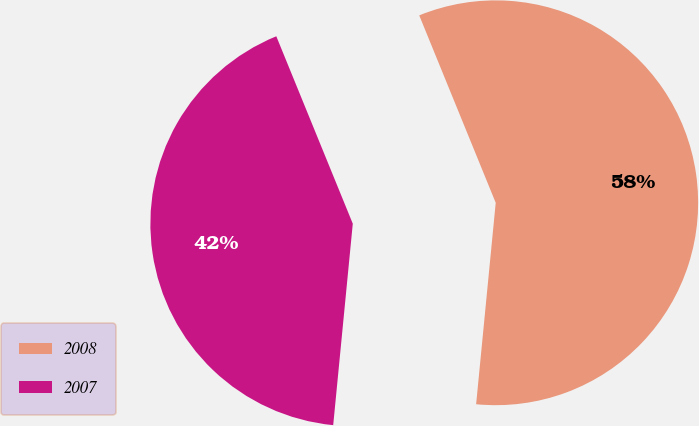<chart> <loc_0><loc_0><loc_500><loc_500><pie_chart><fcel>2008<fcel>2007<nl><fcel>57.71%<fcel>42.29%<nl></chart> 